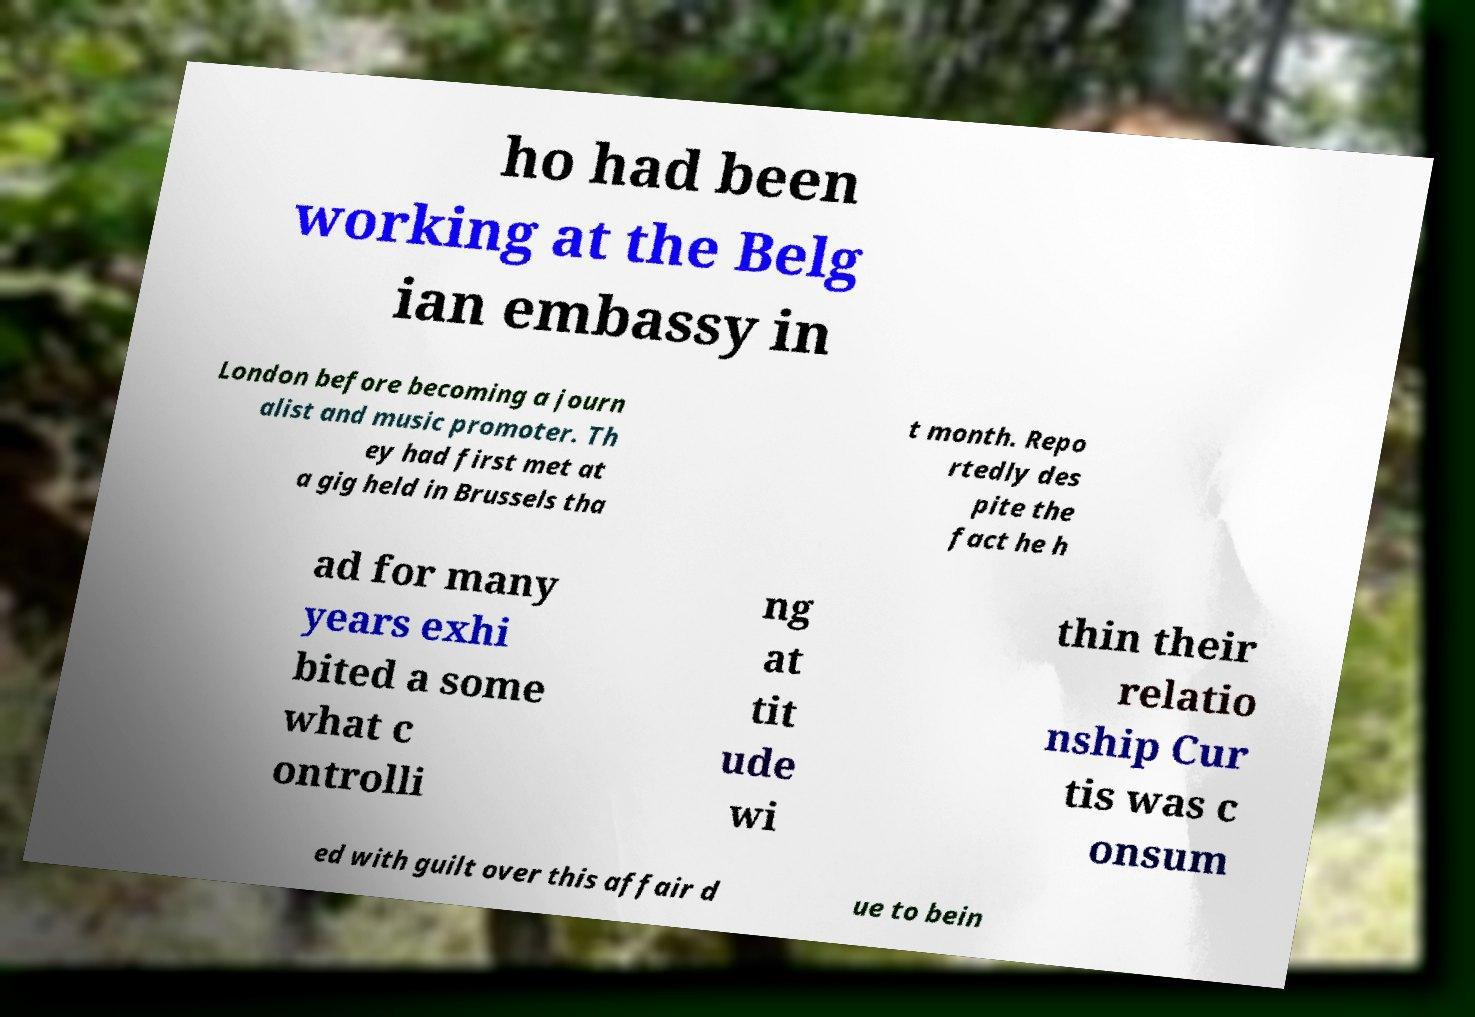There's text embedded in this image that I need extracted. Can you transcribe it verbatim? ho had been working at the Belg ian embassy in London before becoming a journ alist and music promoter. Th ey had first met at a gig held in Brussels tha t month. Repo rtedly des pite the fact he h ad for many years exhi bited a some what c ontrolli ng at tit ude wi thin their relatio nship Cur tis was c onsum ed with guilt over this affair d ue to bein 